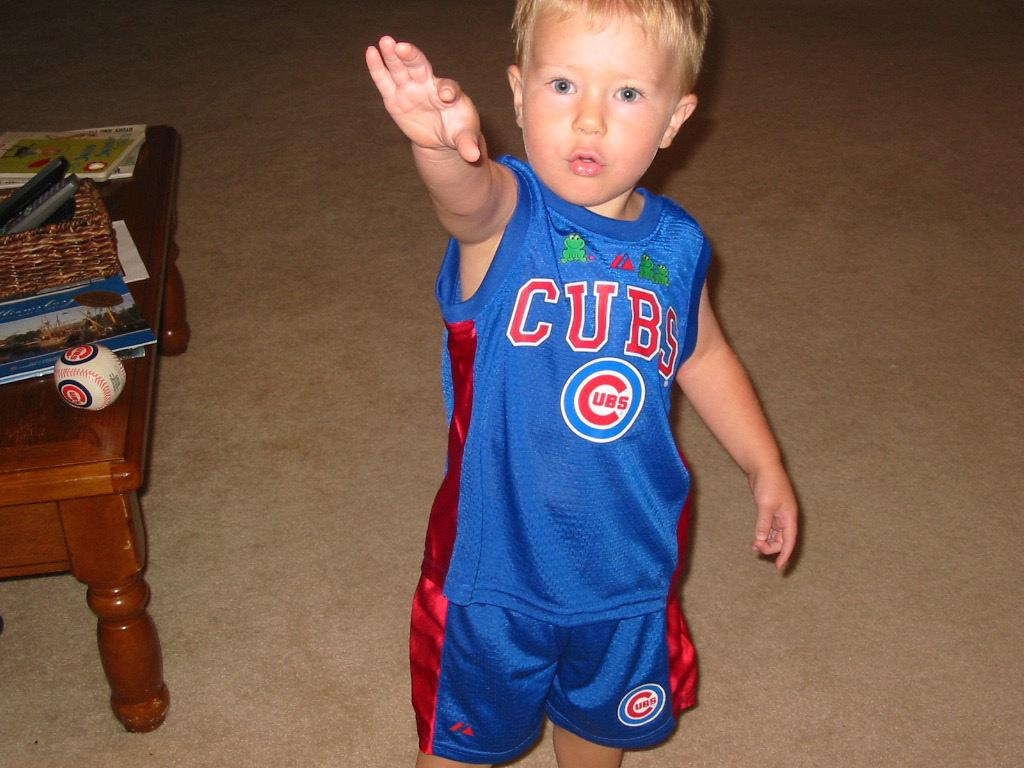<image>
Write a terse but informative summary of the picture. toddler wearing blue and red cubs shirt and shorts 